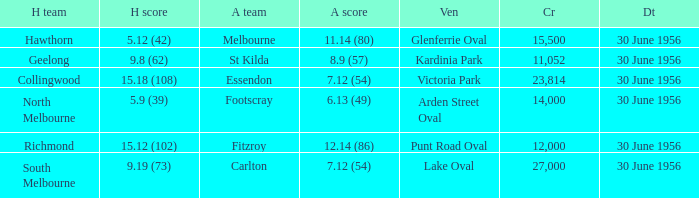What is the home team score when the away team is St Kilda? 9.8 (62). 